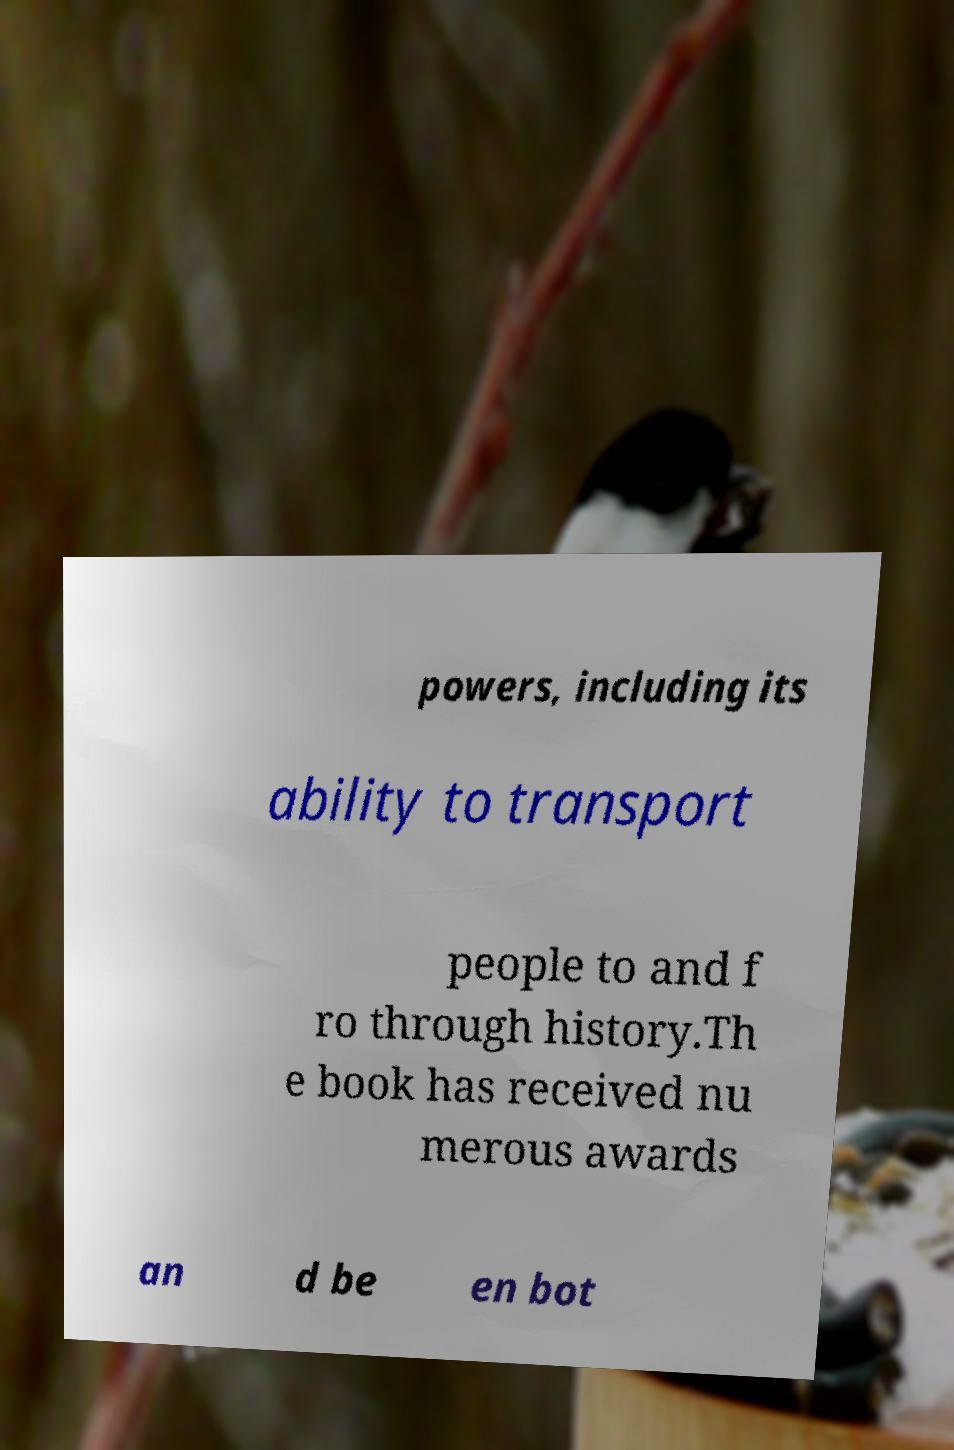Could you assist in decoding the text presented in this image and type it out clearly? powers, including its ability to transport people to and f ro through history.Th e book has received nu merous awards an d be en bot 